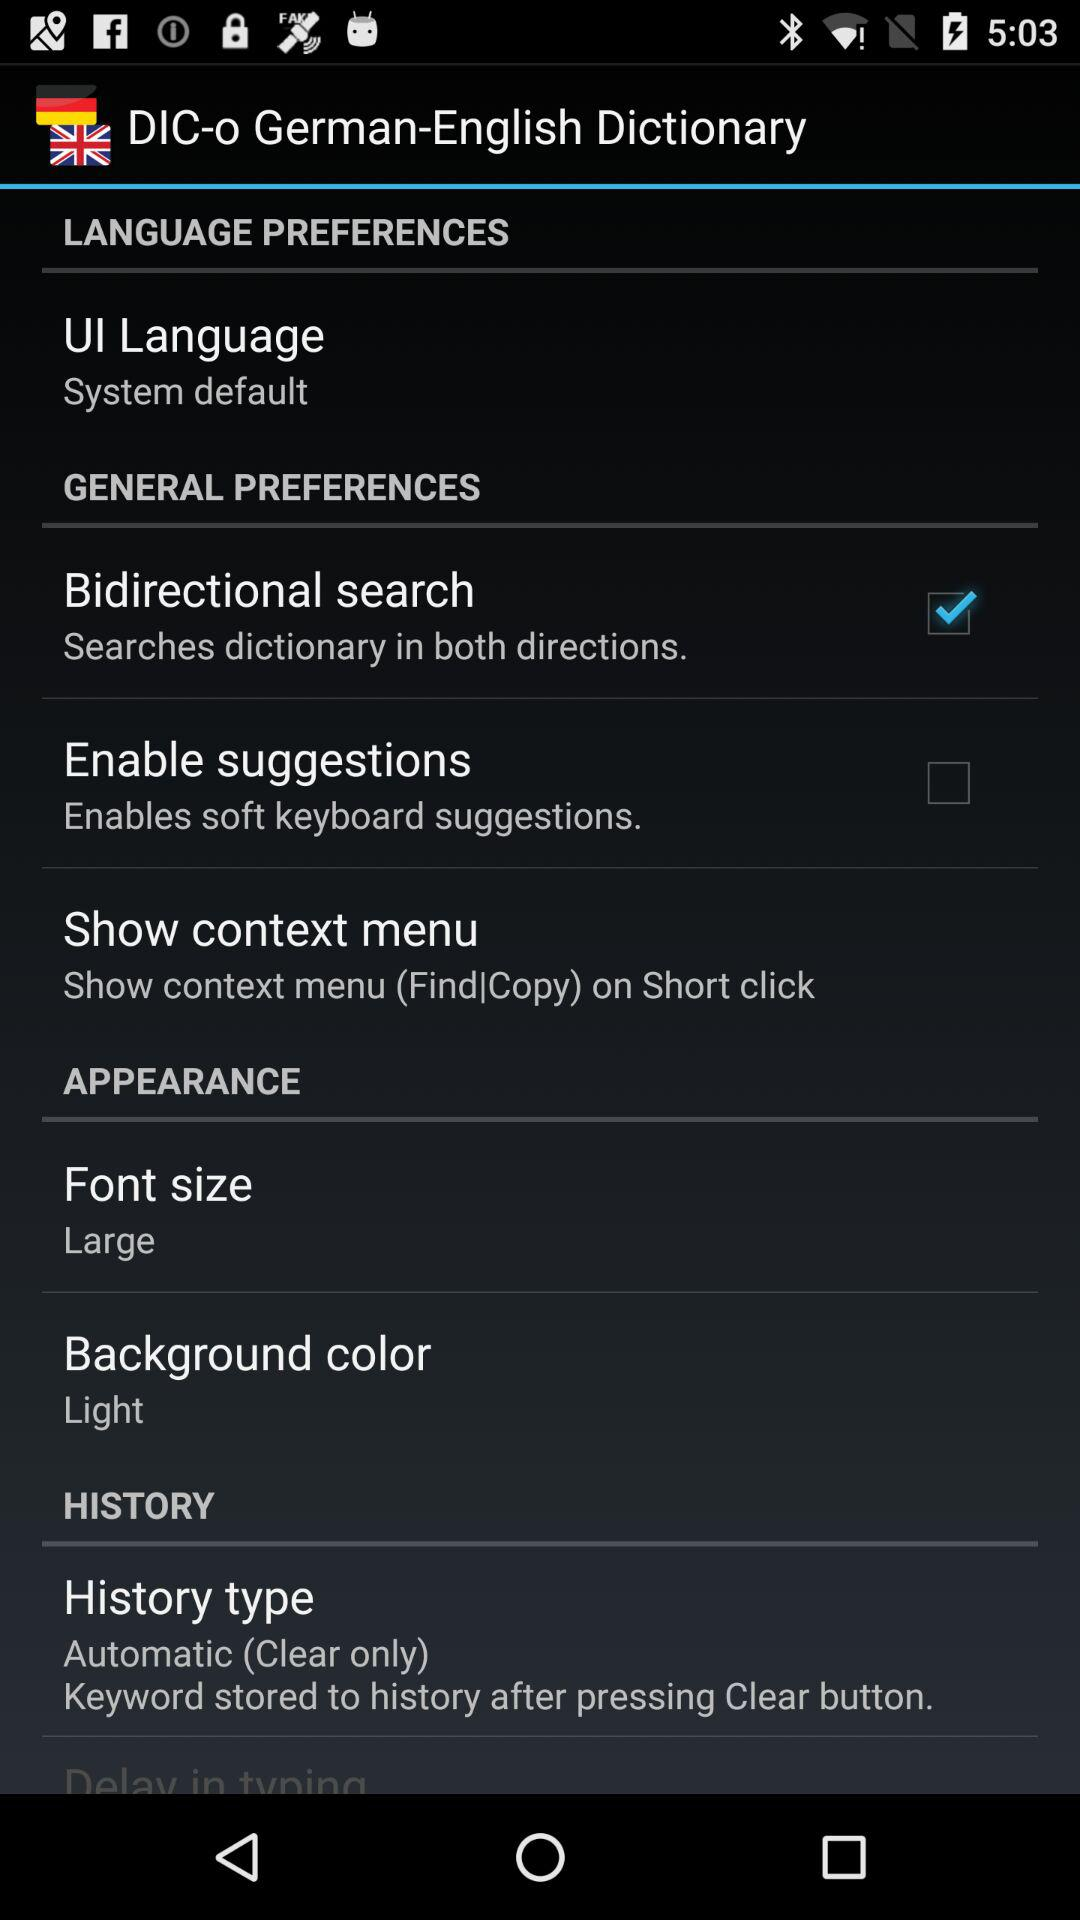What is the UI language preference? The UI language preference is "System default". 